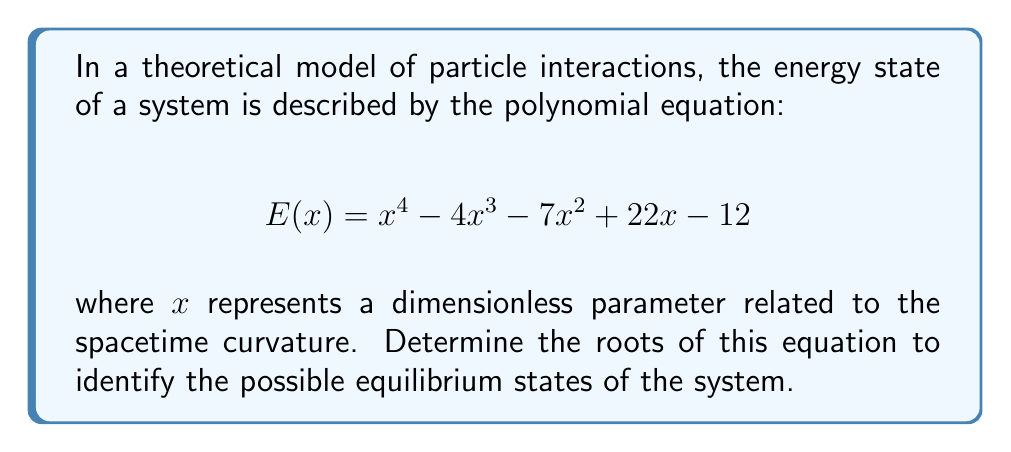Can you solve this math problem? To find the roots of this polynomial equation, we need to factor it or use numerical methods. In this case, we can use the rational root theorem and synthetic division to find the roots.

1) First, let's list the possible rational roots using the rational root theorem:
   Factors of the constant term (12): ±1, ±2, ±3, ±4, ±6, ±12
   
2) We can test these potential roots using synthetic division. Let's start with 1:

   $$
   \begin{array}{r}
   1 \enclose{longdiv}{1 \quad -4 \quad -7 \quad 22 \quad -12} \\
      \underline{1 \quad -3 \quad -10 \quad 12} \\
      1 \quad -3 \quad -10 \quad 12 \quad 0
   \end{array}
   $$

   We found our first root: $x = 1$

3) Now we can divide the original polynomial by $(x-1)$:

   $E(x) = (x-1)(x^3 - 3x^2 - 10x + 12)$

4) Let's factor the cubic polynomial. Testing the remaining potential roots, we find that 3 is also a root:

   $$
   \begin{array}{r}
   3 \enclose{longdiv}{1 \quad -3 \quad -10 \quad 12} \\
      \underline{3 \quad 0 \quad -30} \\
      1 \quad 0 \quad -10 \quad -18 \quad 0
   \end{array}
   $$

5) Now we have:

   $E(x) = (x-1)(x-3)(x^2 + 0x - 4)$

6) The quadratic factor can be solved using the quadratic formula:

   $x = \frac{-b \pm \sqrt{b^2 - 4ac}}{2a} = \frac{0 \pm \sqrt{0^2 - 4(1)(-4)}}{2(1)} = \frac{\pm \sqrt{16}}{2} = \pm 2$

7) Therefore, the complete factorization is:

   $E(x) = (x-1)(x-3)(x-2)(x+2)$

The roots are $x = 1, 3, 2, -2$.
Answer: $x = -2, 1, 2, 3$ 